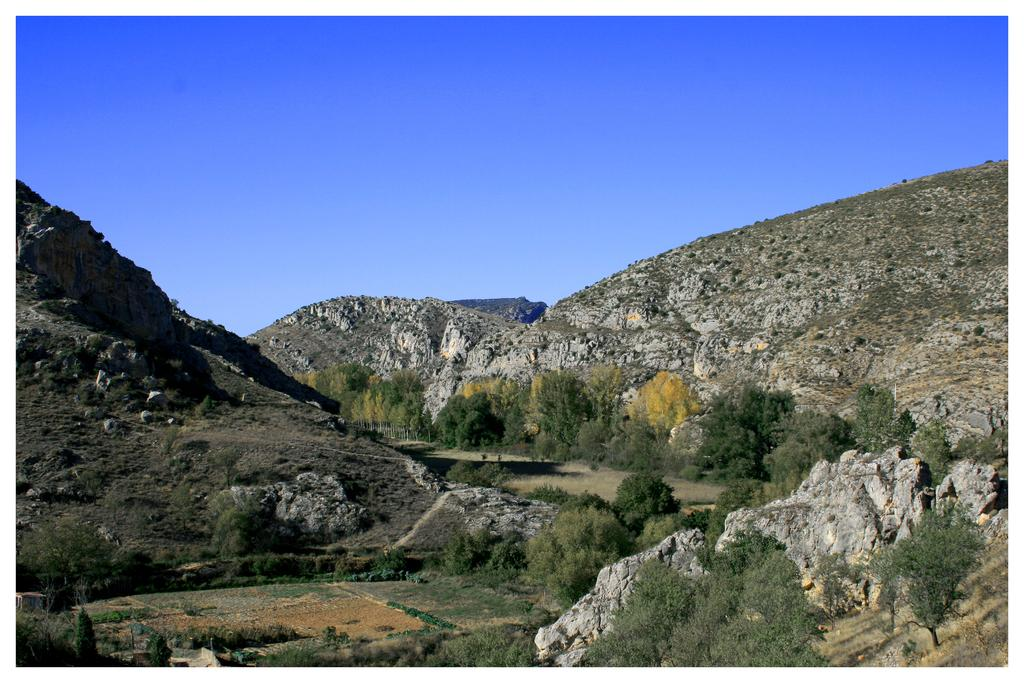What type of vegetation can be seen in the image? There are trees and plants in the image. What is the ground made of in the image? The ground is grassy land in the image. What type of geographical feature is visible in the image? There are mountains in the image. What is visible at the top of the image? The sky is visible at the top of the image. Can you tell me how many clams are buried in the grassy land in the image? There are no clams visible in the image; it features trees, plants, mountains, and grassy land. What type of pleasure can be seen being experienced by the trees in the image? There is no indication of pleasure being experienced by the trees or any other elements in the image. 